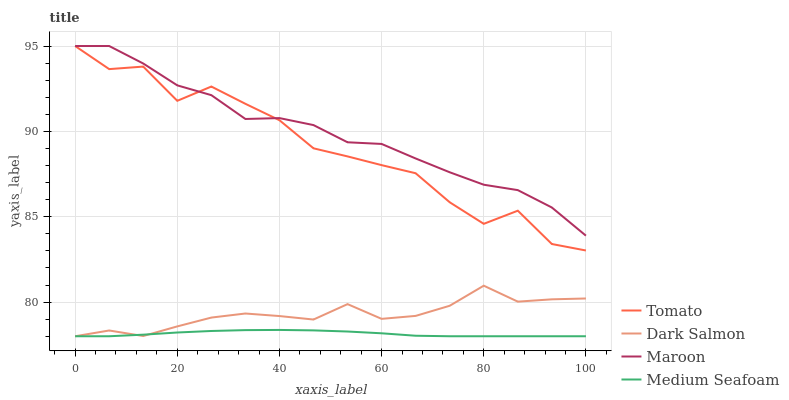Does Medium Seafoam have the minimum area under the curve?
Answer yes or no. Yes. Does Maroon have the maximum area under the curve?
Answer yes or no. Yes. Does Dark Salmon have the minimum area under the curve?
Answer yes or no. No. Does Dark Salmon have the maximum area under the curve?
Answer yes or no. No. Is Medium Seafoam the smoothest?
Answer yes or no. Yes. Is Tomato the roughest?
Answer yes or no. Yes. Is Dark Salmon the smoothest?
Answer yes or no. No. Is Dark Salmon the roughest?
Answer yes or no. No. Does Maroon have the lowest value?
Answer yes or no. No. Does Dark Salmon have the highest value?
Answer yes or no. No. Is Dark Salmon less than Maroon?
Answer yes or no. Yes. Is Tomato greater than Medium Seafoam?
Answer yes or no. Yes. Does Dark Salmon intersect Maroon?
Answer yes or no. No. 